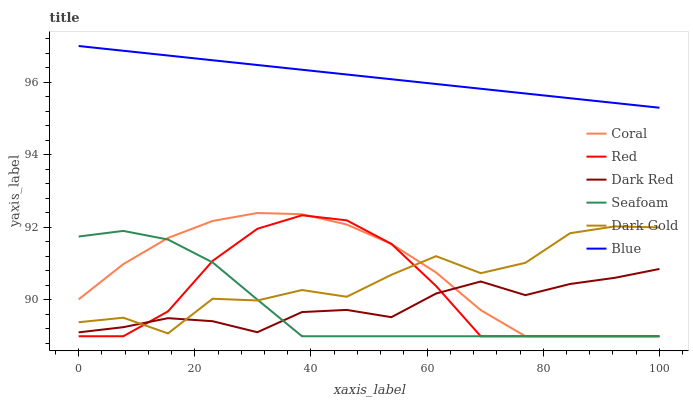Does Seafoam have the minimum area under the curve?
Answer yes or no. Yes. Does Blue have the maximum area under the curve?
Answer yes or no. Yes. Does Dark Gold have the minimum area under the curve?
Answer yes or no. No. Does Dark Gold have the maximum area under the curve?
Answer yes or no. No. Is Blue the smoothest?
Answer yes or no. Yes. Is Dark Gold the roughest?
Answer yes or no. Yes. Is Dark Red the smoothest?
Answer yes or no. No. Is Dark Red the roughest?
Answer yes or no. No. Does Coral have the lowest value?
Answer yes or no. Yes. Does Dark Gold have the lowest value?
Answer yes or no. No. Does Blue have the highest value?
Answer yes or no. Yes. Does Dark Gold have the highest value?
Answer yes or no. No. Is Dark Red less than Blue?
Answer yes or no. Yes. Is Blue greater than Coral?
Answer yes or no. Yes. Does Dark Red intersect Coral?
Answer yes or no. Yes. Is Dark Red less than Coral?
Answer yes or no. No. Is Dark Red greater than Coral?
Answer yes or no. No. Does Dark Red intersect Blue?
Answer yes or no. No. 